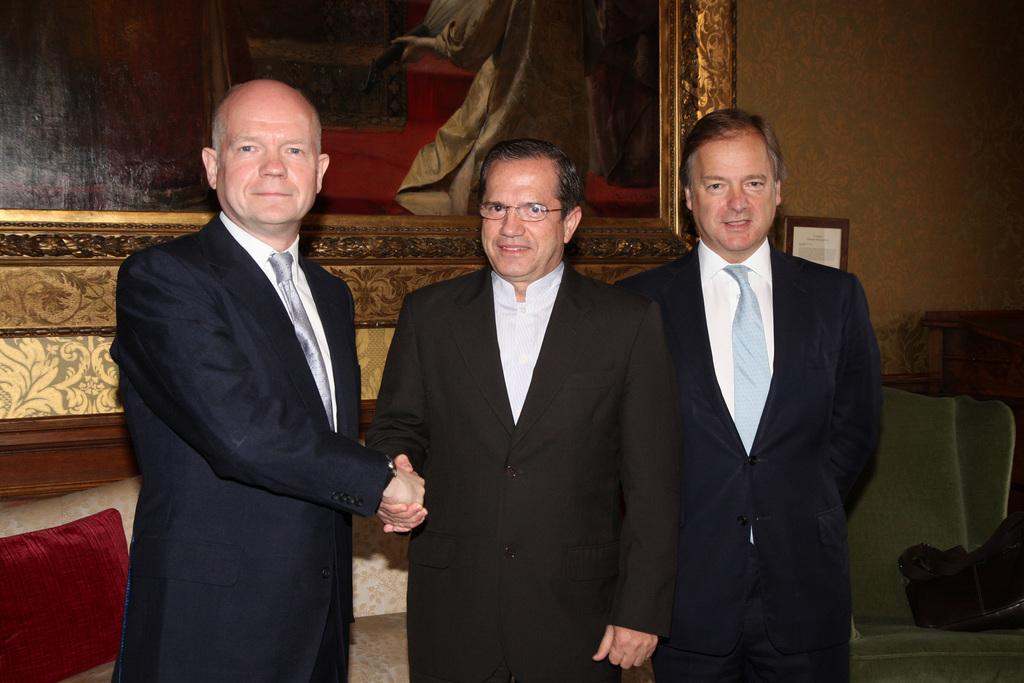What can be seen in the image in terms of people? There are men standing in the image. Can you describe any specific features of one of the men? One man is wearing spectacles. What is present on the wall in the image? There is a photo frame on the wall. What type of furniture is visible in the image? There is a sofa with a cushion and a chair on the side in the image. What type of lead is being used by the men in the image? There is no lead present in the image; the men are simply standing. Can you see any rail in the image? There is no rail present in the image. 